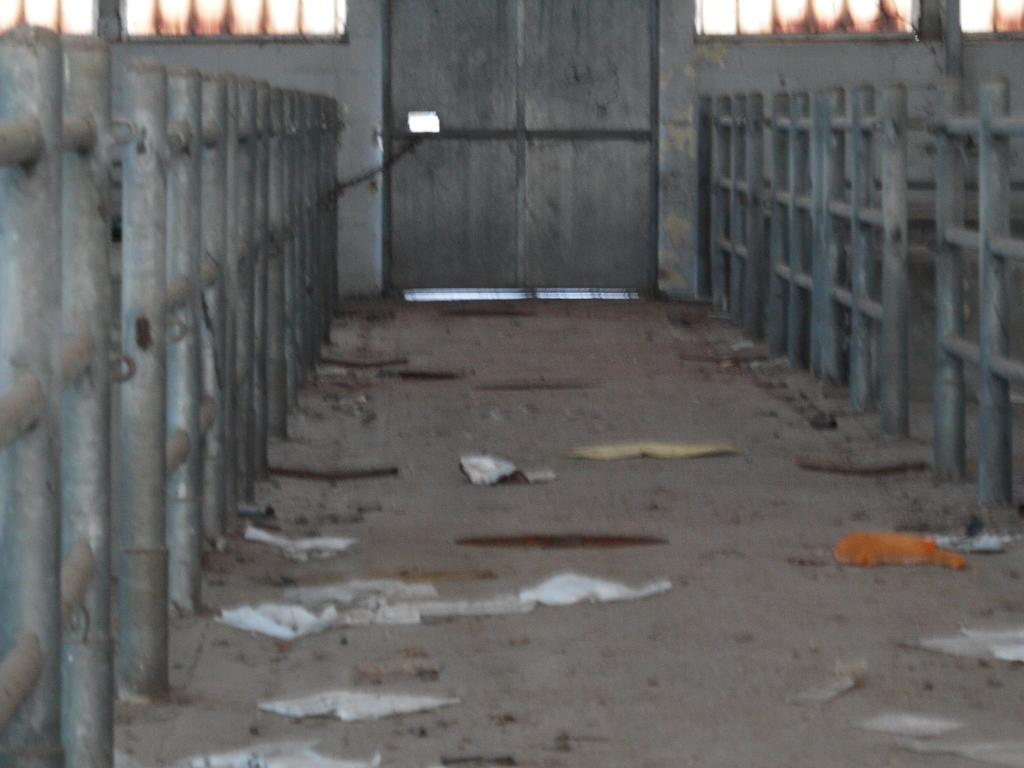What type of structure is visible in the image? There is a gate in the image. What feature can be seen on the gate? There are railings in the image. What objects are on the ground in the image? Papers are present on the ground in the image. What type of honey can be seen dripping from the gate in the image? There is no honey present in the image; it features a gate with railings and papers on the ground. How does the coal affect the appearance of the railings in the image? There is no coal present in the image, so its effect on the railings cannot be determined. 